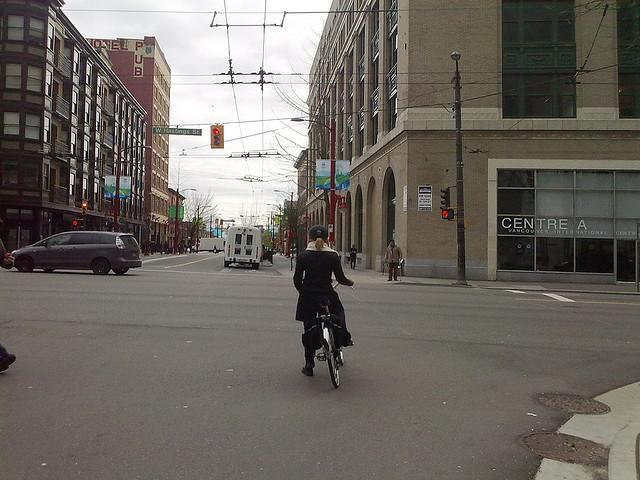How many people are riding a bicycle?
Give a very brief answer. 1. How many stop lights are visible?
Give a very brief answer. 3. How many people are shown?
Give a very brief answer. 1. How many orange cups are on the table?
Give a very brief answer. 0. 